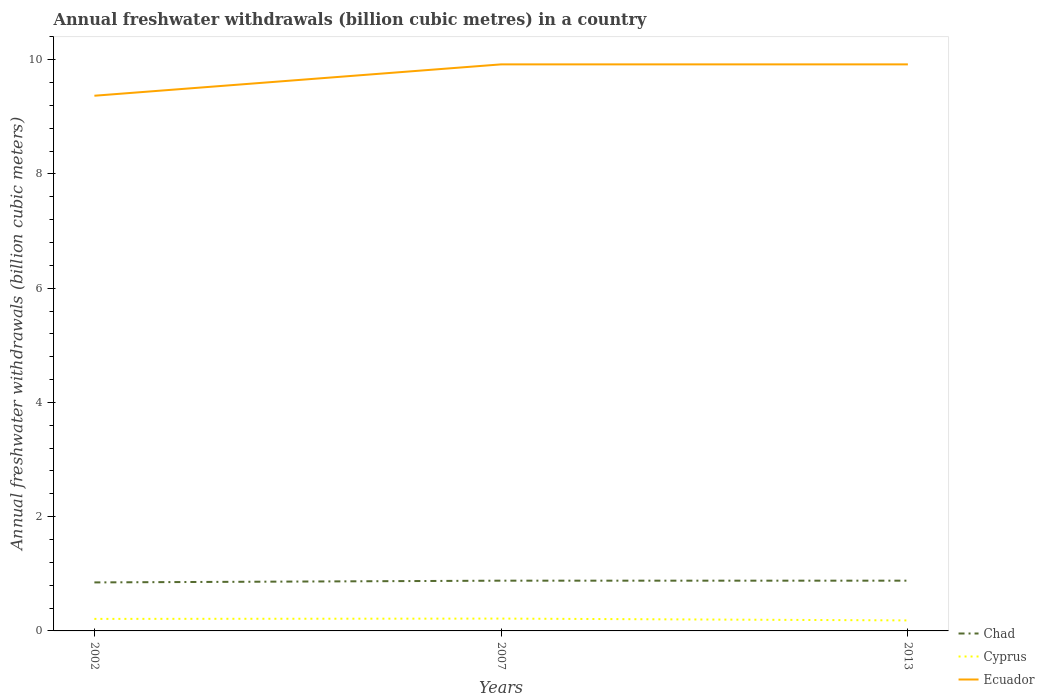How many different coloured lines are there?
Provide a succinct answer. 3. Does the line corresponding to Ecuador intersect with the line corresponding to Cyprus?
Your answer should be compact. No. Across all years, what is the maximum annual freshwater withdrawals in Ecuador?
Ensure brevity in your answer.  9.37. What is the total annual freshwater withdrawals in Chad in the graph?
Give a very brief answer. -0.03. What is the difference between the highest and the second highest annual freshwater withdrawals in Chad?
Your response must be concise. 0.03. Is the annual freshwater withdrawals in Chad strictly greater than the annual freshwater withdrawals in Ecuador over the years?
Provide a short and direct response. Yes. How many years are there in the graph?
Your response must be concise. 3. What is the difference between two consecutive major ticks on the Y-axis?
Offer a very short reply. 2. Does the graph contain any zero values?
Ensure brevity in your answer.  No. Does the graph contain grids?
Provide a short and direct response. No. Where does the legend appear in the graph?
Your answer should be very brief. Bottom right. What is the title of the graph?
Make the answer very short. Annual freshwater withdrawals (billion cubic metres) in a country. Does "Algeria" appear as one of the legend labels in the graph?
Provide a short and direct response. No. What is the label or title of the Y-axis?
Ensure brevity in your answer.  Annual freshwater withdrawals (billion cubic meters). What is the Annual freshwater withdrawals (billion cubic meters) of Chad in 2002?
Provide a succinct answer. 0.85. What is the Annual freshwater withdrawals (billion cubic meters) of Cyprus in 2002?
Give a very brief answer. 0.21. What is the Annual freshwater withdrawals (billion cubic meters) in Ecuador in 2002?
Provide a succinct answer. 9.37. What is the Annual freshwater withdrawals (billion cubic meters) in Chad in 2007?
Provide a short and direct response. 0.88. What is the Annual freshwater withdrawals (billion cubic meters) in Cyprus in 2007?
Give a very brief answer. 0.22. What is the Annual freshwater withdrawals (billion cubic meters) in Ecuador in 2007?
Ensure brevity in your answer.  9.92. What is the Annual freshwater withdrawals (billion cubic meters) in Chad in 2013?
Ensure brevity in your answer.  0.88. What is the Annual freshwater withdrawals (billion cubic meters) of Cyprus in 2013?
Offer a terse response. 0.18. What is the Annual freshwater withdrawals (billion cubic meters) of Ecuador in 2013?
Your answer should be very brief. 9.92. Across all years, what is the maximum Annual freshwater withdrawals (billion cubic meters) of Chad?
Provide a short and direct response. 0.88. Across all years, what is the maximum Annual freshwater withdrawals (billion cubic meters) in Cyprus?
Ensure brevity in your answer.  0.22. Across all years, what is the maximum Annual freshwater withdrawals (billion cubic meters) in Ecuador?
Make the answer very short. 9.92. Across all years, what is the minimum Annual freshwater withdrawals (billion cubic meters) of Chad?
Offer a very short reply. 0.85. Across all years, what is the minimum Annual freshwater withdrawals (billion cubic meters) in Cyprus?
Your answer should be compact. 0.18. Across all years, what is the minimum Annual freshwater withdrawals (billion cubic meters) in Ecuador?
Give a very brief answer. 9.37. What is the total Annual freshwater withdrawals (billion cubic meters) of Chad in the graph?
Offer a terse response. 2.61. What is the total Annual freshwater withdrawals (billion cubic meters) in Cyprus in the graph?
Ensure brevity in your answer.  0.61. What is the total Annual freshwater withdrawals (billion cubic meters) in Ecuador in the graph?
Provide a succinct answer. 29.2. What is the difference between the Annual freshwater withdrawals (billion cubic meters) of Chad in 2002 and that in 2007?
Make the answer very short. -0.03. What is the difference between the Annual freshwater withdrawals (billion cubic meters) of Cyprus in 2002 and that in 2007?
Keep it short and to the point. -0.01. What is the difference between the Annual freshwater withdrawals (billion cubic meters) of Ecuador in 2002 and that in 2007?
Make the answer very short. -0.55. What is the difference between the Annual freshwater withdrawals (billion cubic meters) of Chad in 2002 and that in 2013?
Make the answer very short. -0.03. What is the difference between the Annual freshwater withdrawals (billion cubic meters) in Cyprus in 2002 and that in 2013?
Offer a terse response. 0.03. What is the difference between the Annual freshwater withdrawals (billion cubic meters) of Ecuador in 2002 and that in 2013?
Your answer should be compact. -0.55. What is the difference between the Annual freshwater withdrawals (billion cubic meters) of Chad in 2007 and that in 2013?
Provide a succinct answer. 0. What is the difference between the Annual freshwater withdrawals (billion cubic meters) in Cyprus in 2007 and that in 2013?
Provide a succinct answer. 0.03. What is the difference between the Annual freshwater withdrawals (billion cubic meters) of Chad in 2002 and the Annual freshwater withdrawals (billion cubic meters) of Cyprus in 2007?
Provide a short and direct response. 0.63. What is the difference between the Annual freshwater withdrawals (billion cubic meters) in Chad in 2002 and the Annual freshwater withdrawals (billion cubic meters) in Ecuador in 2007?
Give a very brief answer. -9.07. What is the difference between the Annual freshwater withdrawals (billion cubic meters) in Cyprus in 2002 and the Annual freshwater withdrawals (billion cubic meters) in Ecuador in 2007?
Your answer should be very brief. -9.71. What is the difference between the Annual freshwater withdrawals (billion cubic meters) of Chad in 2002 and the Annual freshwater withdrawals (billion cubic meters) of Cyprus in 2013?
Provide a short and direct response. 0.67. What is the difference between the Annual freshwater withdrawals (billion cubic meters) of Chad in 2002 and the Annual freshwater withdrawals (billion cubic meters) of Ecuador in 2013?
Keep it short and to the point. -9.07. What is the difference between the Annual freshwater withdrawals (billion cubic meters) of Cyprus in 2002 and the Annual freshwater withdrawals (billion cubic meters) of Ecuador in 2013?
Offer a terse response. -9.71. What is the difference between the Annual freshwater withdrawals (billion cubic meters) of Chad in 2007 and the Annual freshwater withdrawals (billion cubic meters) of Cyprus in 2013?
Offer a terse response. 0.7. What is the difference between the Annual freshwater withdrawals (billion cubic meters) in Chad in 2007 and the Annual freshwater withdrawals (billion cubic meters) in Ecuador in 2013?
Make the answer very short. -9.04. What is the difference between the Annual freshwater withdrawals (billion cubic meters) of Cyprus in 2007 and the Annual freshwater withdrawals (billion cubic meters) of Ecuador in 2013?
Keep it short and to the point. -9.7. What is the average Annual freshwater withdrawals (billion cubic meters) in Chad per year?
Your answer should be compact. 0.87. What is the average Annual freshwater withdrawals (billion cubic meters) of Cyprus per year?
Keep it short and to the point. 0.2. What is the average Annual freshwater withdrawals (billion cubic meters) of Ecuador per year?
Ensure brevity in your answer.  9.73. In the year 2002, what is the difference between the Annual freshwater withdrawals (billion cubic meters) of Chad and Annual freshwater withdrawals (billion cubic meters) of Cyprus?
Provide a short and direct response. 0.64. In the year 2002, what is the difference between the Annual freshwater withdrawals (billion cubic meters) in Chad and Annual freshwater withdrawals (billion cubic meters) in Ecuador?
Ensure brevity in your answer.  -8.52. In the year 2002, what is the difference between the Annual freshwater withdrawals (billion cubic meters) of Cyprus and Annual freshwater withdrawals (billion cubic meters) of Ecuador?
Keep it short and to the point. -9.16. In the year 2007, what is the difference between the Annual freshwater withdrawals (billion cubic meters) in Chad and Annual freshwater withdrawals (billion cubic meters) in Cyprus?
Ensure brevity in your answer.  0.66. In the year 2007, what is the difference between the Annual freshwater withdrawals (billion cubic meters) in Chad and Annual freshwater withdrawals (billion cubic meters) in Ecuador?
Keep it short and to the point. -9.04. In the year 2007, what is the difference between the Annual freshwater withdrawals (billion cubic meters) of Cyprus and Annual freshwater withdrawals (billion cubic meters) of Ecuador?
Your response must be concise. -9.7. In the year 2013, what is the difference between the Annual freshwater withdrawals (billion cubic meters) of Chad and Annual freshwater withdrawals (billion cubic meters) of Cyprus?
Your answer should be very brief. 0.7. In the year 2013, what is the difference between the Annual freshwater withdrawals (billion cubic meters) in Chad and Annual freshwater withdrawals (billion cubic meters) in Ecuador?
Keep it short and to the point. -9.04. In the year 2013, what is the difference between the Annual freshwater withdrawals (billion cubic meters) in Cyprus and Annual freshwater withdrawals (billion cubic meters) in Ecuador?
Make the answer very short. -9.73. What is the ratio of the Annual freshwater withdrawals (billion cubic meters) of Chad in 2002 to that in 2007?
Keep it short and to the point. 0.97. What is the ratio of the Annual freshwater withdrawals (billion cubic meters) in Cyprus in 2002 to that in 2007?
Provide a succinct answer. 0.97. What is the ratio of the Annual freshwater withdrawals (billion cubic meters) in Ecuador in 2002 to that in 2007?
Your answer should be compact. 0.94. What is the ratio of the Annual freshwater withdrawals (billion cubic meters) in Chad in 2002 to that in 2013?
Your answer should be compact. 0.97. What is the ratio of the Annual freshwater withdrawals (billion cubic meters) of Cyprus in 2002 to that in 2013?
Offer a terse response. 1.14. What is the ratio of the Annual freshwater withdrawals (billion cubic meters) in Ecuador in 2002 to that in 2013?
Provide a succinct answer. 0.94. What is the ratio of the Annual freshwater withdrawals (billion cubic meters) of Cyprus in 2007 to that in 2013?
Your answer should be compact. 1.17. What is the difference between the highest and the second highest Annual freshwater withdrawals (billion cubic meters) in Cyprus?
Your answer should be very brief. 0.01. What is the difference between the highest and the second highest Annual freshwater withdrawals (billion cubic meters) in Ecuador?
Ensure brevity in your answer.  0. What is the difference between the highest and the lowest Annual freshwater withdrawals (billion cubic meters) of Chad?
Your response must be concise. 0.03. What is the difference between the highest and the lowest Annual freshwater withdrawals (billion cubic meters) of Cyprus?
Your response must be concise. 0.03. What is the difference between the highest and the lowest Annual freshwater withdrawals (billion cubic meters) in Ecuador?
Keep it short and to the point. 0.55. 